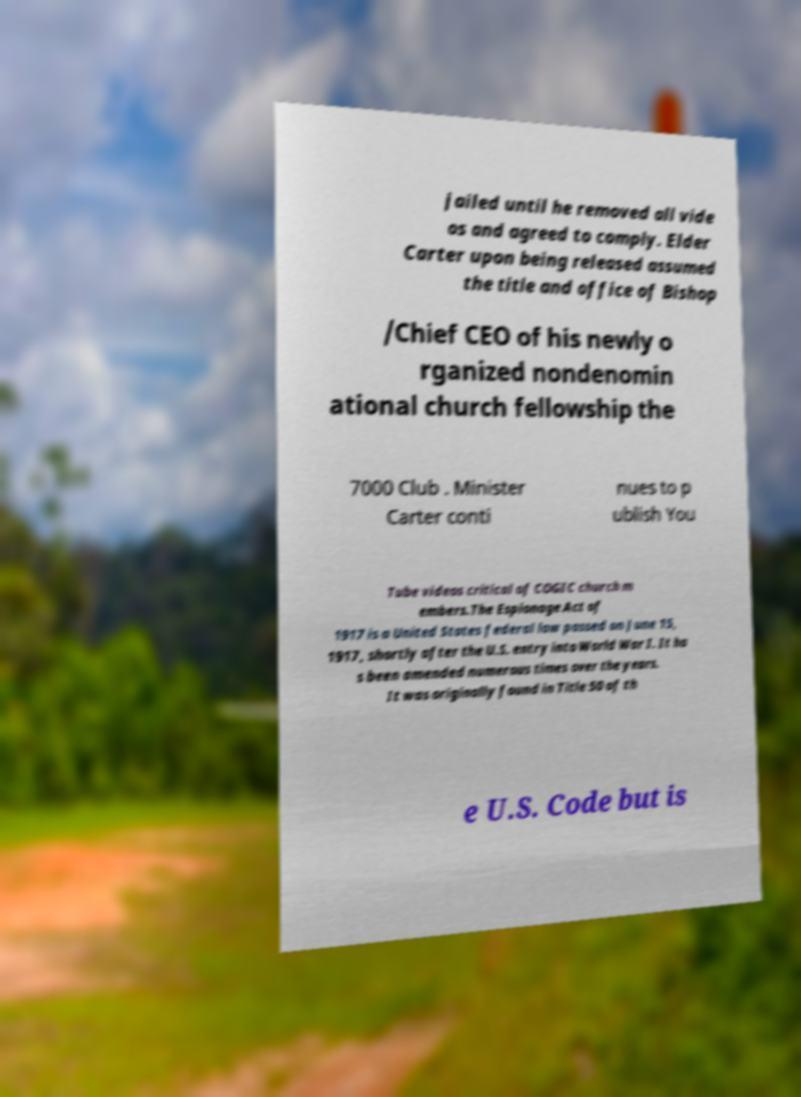Please read and relay the text visible in this image. What does it say? jailed until he removed all vide os and agreed to comply. Elder Carter upon being released assumed the title and office of Bishop /Chief CEO of his newly o rganized nondenomin ational church fellowship the 7000 Club . Minister Carter conti nues to p ublish You Tube videos critical of COGIC church m embers.The Espionage Act of 1917 is a United States federal law passed on June 15, 1917, shortly after the U.S. entry into World War I. It ha s been amended numerous times over the years. It was originally found in Title 50 of th e U.S. Code but is 